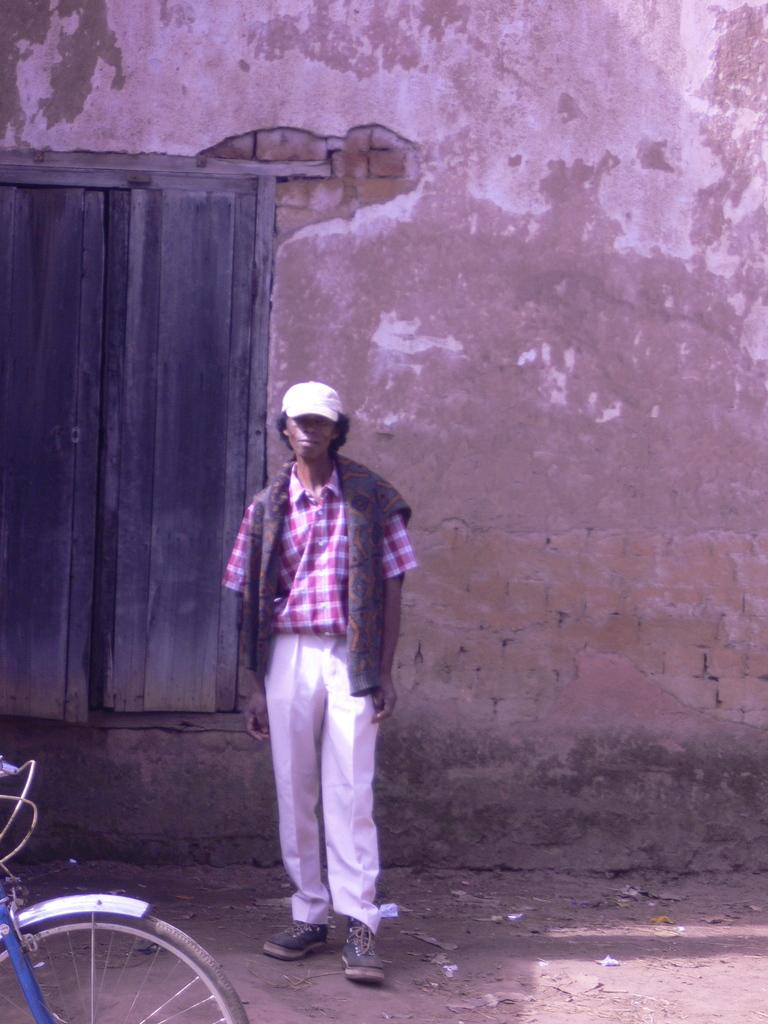What is the main subject of the image? There is a person standing in the image. Where is the person standing? The person is standing on the ground. What can be seen in the background of the image? There is a door and a wall in the background of the image. What object is on the left side of the image? There is a bicycle on the left side of the image. What type of cloth is draped over the light in the image? There is no light or cloth present in the image. How many wheels are visible on the bicycle in the image? The bicycle in the image has two wheels. 